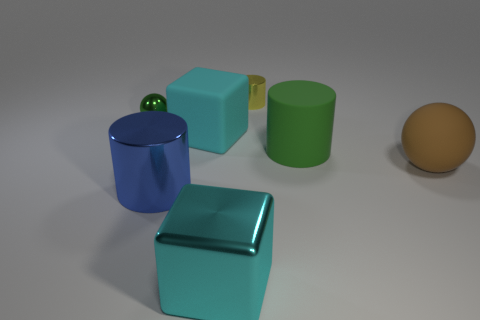Subtract all big cylinders. How many cylinders are left? 1 Subtract 1 cylinders. How many cylinders are left? 2 Add 2 cyan rubber blocks. How many objects exist? 9 Subtract all balls. How many objects are left? 5 Add 7 large yellow matte cylinders. How many large yellow matte cylinders exist? 7 Subtract 0 green blocks. How many objects are left? 7 Subtract all small objects. Subtract all cyan matte blocks. How many objects are left? 4 Add 2 tiny green things. How many tiny green things are left? 3 